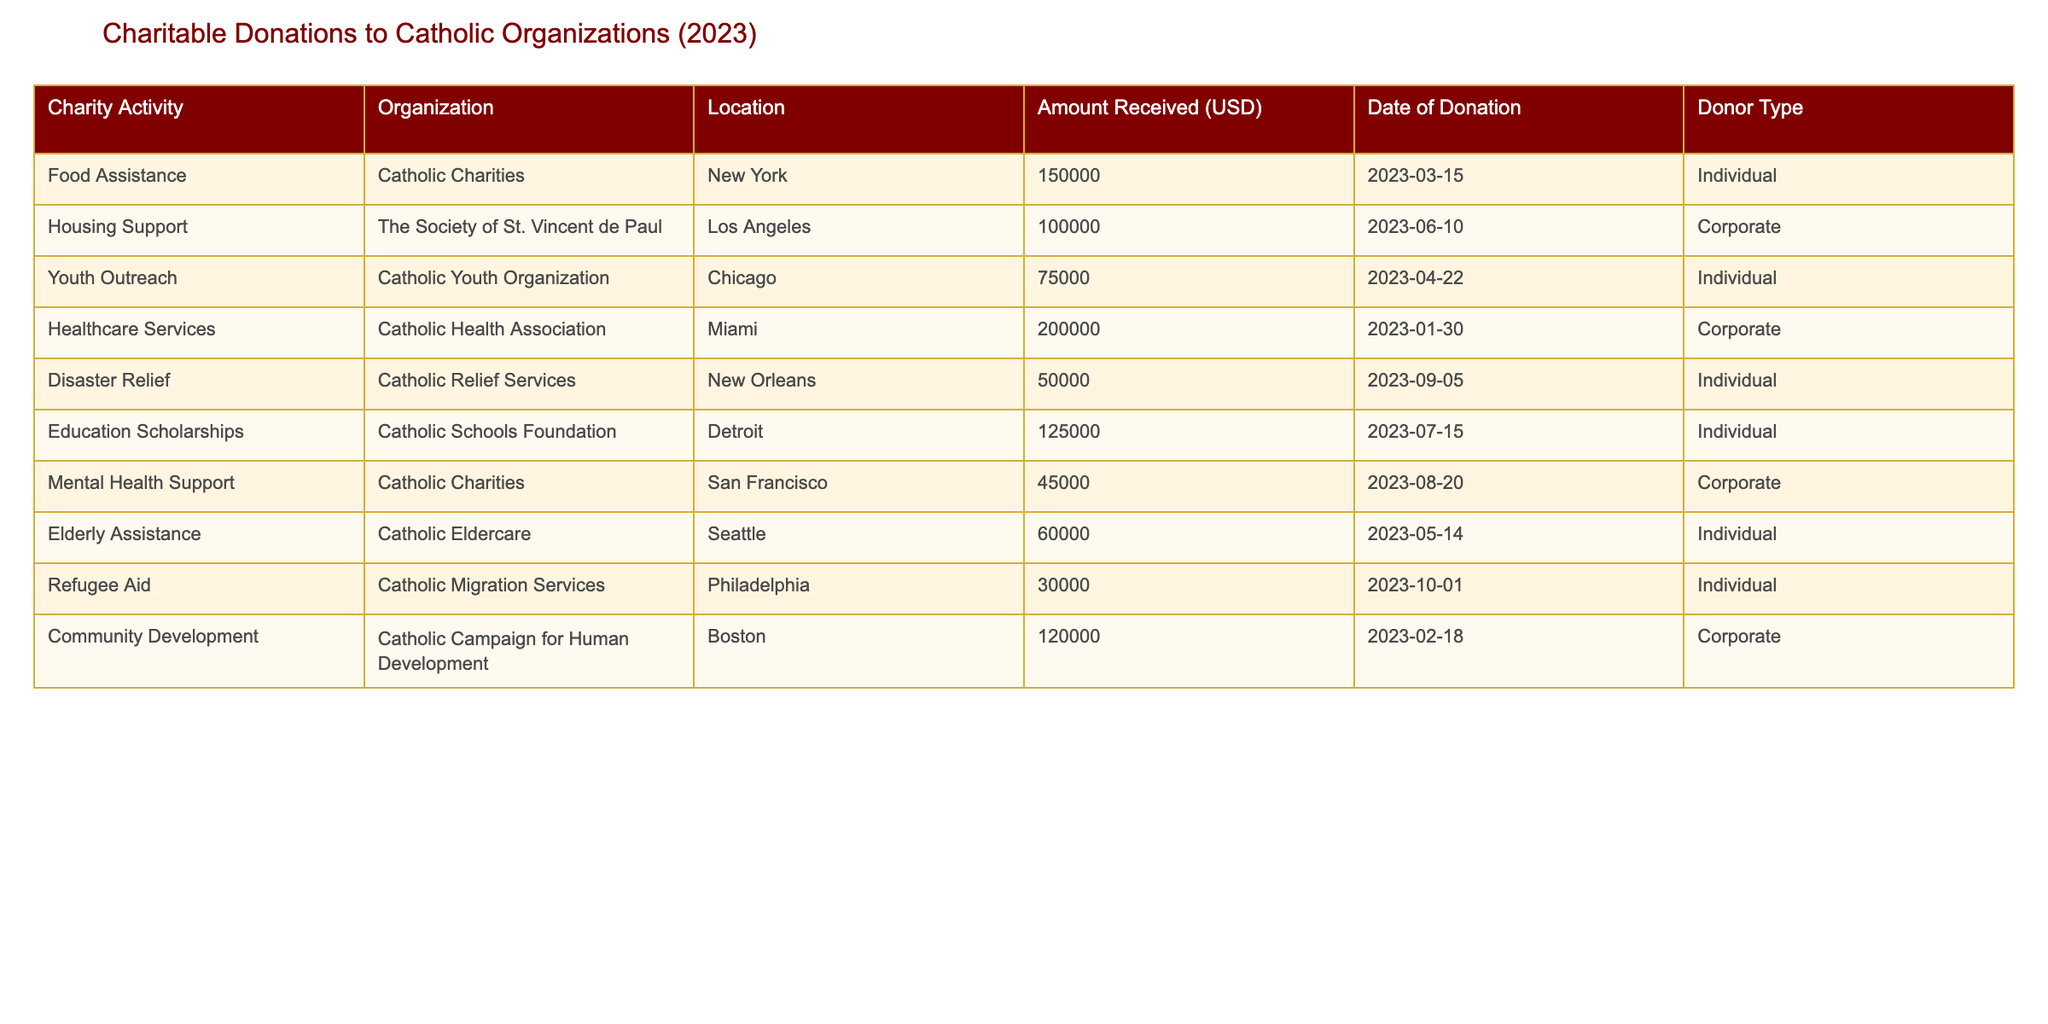What is the total amount received for Food Assistance in New York? In the table, under the "Food Assistance" charity activity, the "Amount Received" is listed as 150000 USD for New York.
Answer: 150000 What organization received the highest donation amount? Looking through the "Amount Received" column, the highest value is 200000 USD attributed to the "Healthcare Services" donation received by the Catholic Health Association.
Answer: Catholic Health Association How much was donated to community development in Boston? According to the table, the "Community Development" charity activity lists an amount of 120000 USD for Boston.
Answer: 120000 Did any individual donors contribute to Healthcare Services? By examining the "Donor Type" for the "Healthcare Services" donation, it shows that the donor type is listed as "Corporate," indicating no individual donors contributed.
Answer: No What is the average amount donated across all charity activities? To find the average, I sum the amounts received (150000 + 100000 + 75000 + 200000 + 50000 + 125000 + 45000 + 60000 + 30000 + 120000) = 930000, and then divide by the number of charity activities, which is 10. Therefore, the average is 930000 / 10 = 93000.
Answer: 93000 Was there any donation for elderly assistance? The table shows that "Elderly Assistance" received 60000 USD, confirming that there was a donation for this activity.
Answer: Yes Which charity had the lowest donation amount and how much was it? By reviewing the "Amount Received" column, the lowest value is 30000 USD for "Refugee Aid."
Answer: Refugee Aid, 30000 How many donations were received from individual donors? In the "Donor Type" column, I count individual donors: Food Assistance, Youth Outreach, Disaster Relief, Education Scholarships, Elderly Assistance, and Refugee Aid, totaling 6 donations from individuals.
Answer: 6 What is the total amount received from corporate donations? The corporate donations are from Housing Support (100000), Healthcare Services (200000), Mental Health Support (45000), and Community Development (120000). Summing these amounts gives: 100000 + 200000 + 45000 + 120000 = 465000.
Answer: 465000 